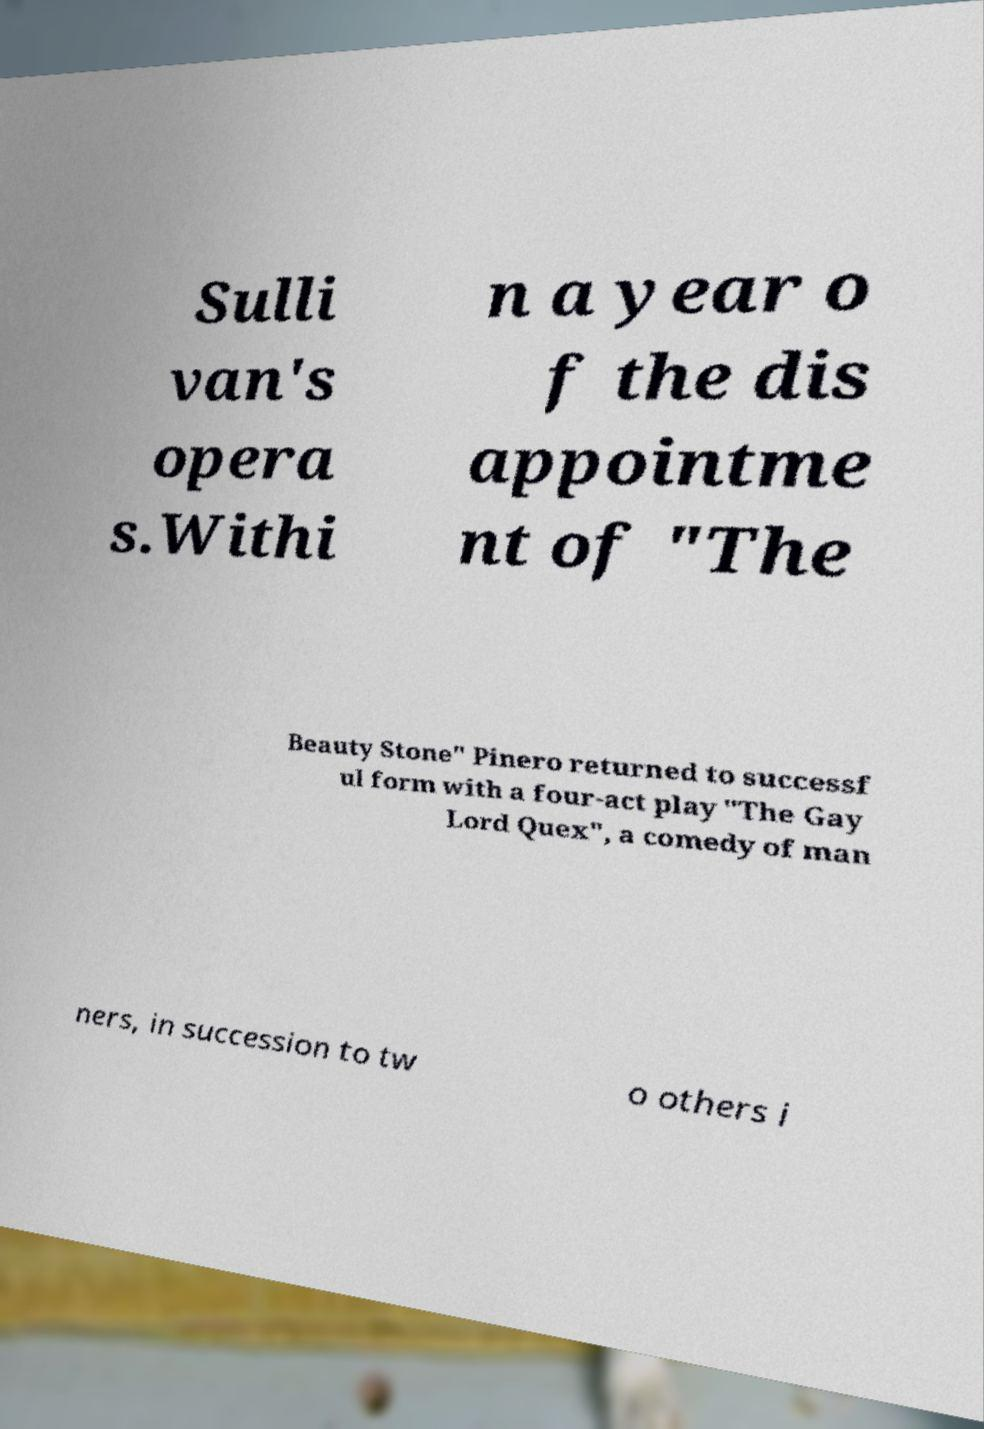I need the written content from this picture converted into text. Can you do that? Sulli van's opera s.Withi n a year o f the dis appointme nt of "The Beauty Stone" Pinero returned to successf ul form with a four-act play "The Gay Lord Quex", a comedy of man ners, in succession to tw o others i 